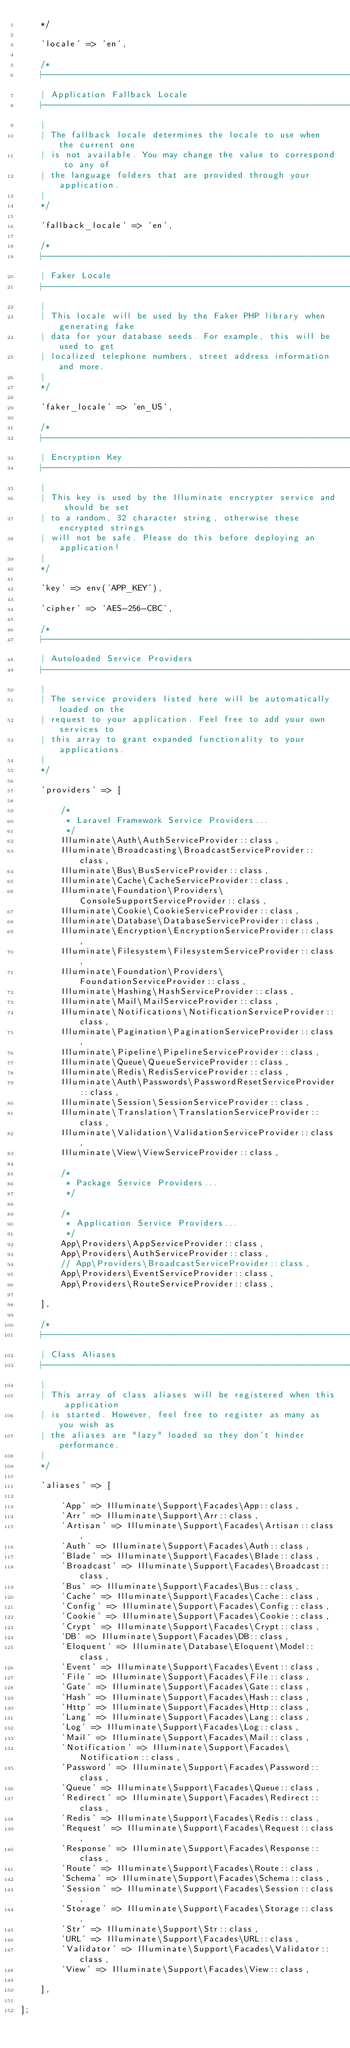Convert code to text. <code><loc_0><loc_0><loc_500><loc_500><_PHP_>    */

    'locale' => 'en',

    /*
    |--------------------------------------------------------------------------
    | Application Fallback Locale
    |--------------------------------------------------------------------------
    |
    | The fallback locale determines the locale to use when the current one
    | is not available. You may change the value to correspond to any of
    | the language folders that are provided through your application.
    |
    */

    'fallback_locale' => 'en',

    /*
    |--------------------------------------------------------------------------
    | Faker Locale
    |--------------------------------------------------------------------------
    |
    | This locale will be used by the Faker PHP library when generating fake
    | data for your database seeds. For example, this will be used to get
    | localized telephone numbers, street address information and more.
    |
    */

    'faker_locale' => 'en_US',

    /*
    |--------------------------------------------------------------------------
    | Encryption Key
    |--------------------------------------------------------------------------
    |
    | This key is used by the Illuminate encrypter service and should be set
    | to a random, 32 character string, otherwise these encrypted strings
    | will not be safe. Please do this before deploying an application!
    |
    */

    'key' => env('APP_KEY'),

    'cipher' => 'AES-256-CBC',

    /*
    |--------------------------------------------------------------------------
    | Autoloaded Service Providers
    |--------------------------------------------------------------------------
    |
    | The service providers listed here will be automatically loaded on the
    | request to your application. Feel free to add your own services to
    | this array to grant expanded functionality to your applications.
    |
    */

    'providers' => [

        /*
         * Laravel Framework Service Providers...
         */
        Illuminate\Auth\AuthServiceProvider::class,
        Illuminate\Broadcasting\BroadcastServiceProvider::class,
        Illuminate\Bus\BusServiceProvider::class,
        Illuminate\Cache\CacheServiceProvider::class,
        Illuminate\Foundation\Providers\ConsoleSupportServiceProvider::class,
        Illuminate\Cookie\CookieServiceProvider::class,
        Illuminate\Database\DatabaseServiceProvider::class,
        Illuminate\Encryption\EncryptionServiceProvider::class,
        Illuminate\Filesystem\FilesystemServiceProvider::class,
        Illuminate\Foundation\Providers\FoundationServiceProvider::class,
        Illuminate\Hashing\HashServiceProvider::class,
        Illuminate\Mail\MailServiceProvider::class,
        Illuminate\Notifications\NotificationServiceProvider::class,
        Illuminate\Pagination\PaginationServiceProvider::class,
        Illuminate\Pipeline\PipelineServiceProvider::class,
        Illuminate\Queue\QueueServiceProvider::class,
        Illuminate\Redis\RedisServiceProvider::class,
        Illuminate\Auth\Passwords\PasswordResetServiceProvider::class,
        Illuminate\Session\SessionServiceProvider::class,
        Illuminate\Translation\TranslationServiceProvider::class,
        Illuminate\Validation\ValidationServiceProvider::class,
        Illuminate\View\ViewServiceProvider::class,

        /*
         * Package Service Providers...
         */

        /*
         * Application Service Providers...
         */
        App\Providers\AppServiceProvider::class,
        App\Providers\AuthServiceProvider::class,
        // App\Providers\BroadcastServiceProvider::class,
        App\Providers\EventServiceProvider::class,
        App\Providers\RouteServiceProvider::class,

    ],

    /*
    |--------------------------------------------------------------------------
    | Class Aliases
    |--------------------------------------------------------------------------
    |
    | This array of class aliases will be registered when this application
    | is started. However, feel free to register as many as you wish as
    | the aliases are "lazy" loaded so they don't hinder performance.
    |
    */

    'aliases' => [

        'App' => Illuminate\Support\Facades\App::class,
        'Arr' => Illuminate\Support\Arr::class,
        'Artisan' => Illuminate\Support\Facades\Artisan::class,
        'Auth' => Illuminate\Support\Facades\Auth::class,
        'Blade' => Illuminate\Support\Facades\Blade::class,
        'Broadcast' => Illuminate\Support\Facades\Broadcast::class,
        'Bus' => Illuminate\Support\Facades\Bus::class,
        'Cache' => Illuminate\Support\Facades\Cache::class,
        'Config' => Illuminate\Support\Facades\Config::class,
        'Cookie' => Illuminate\Support\Facades\Cookie::class,
        'Crypt' => Illuminate\Support\Facades\Crypt::class,
        'DB' => Illuminate\Support\Facades\DB::class,
        'Eloquent' => Illuminate\Database\Eloquent\Model::class,
        'Event' => Illuminate\Support\Facades\Event::class,
        'File' => Illuminate\Support\Facades\File::class,
        'Gate' => Illuminate\Support\Facades\Gate::class,
        'Hash' => Illuminate\Support\Facades\Hash::class,
        'Http' => Illuminate\Support\Facades\Http::class,
        'Lang' => Illuminate\Support\Facades\Lang::class,
        'Log' => Illuminate\Support\Facades\Log::class,
        'Mail' => Illuminate\Support\Facades\Mail::class,
        'Notification' => Illuminate\Support\Facades\Notification::class,
        'Password' => Illuminate\Support\Facades\Password::class,
        'Queue' => Illuminate\Support\Facades\Queue::class,
        'Redirect' => Illuminate\Support\Facades\Redirect::class,
        'Redis' => Illuminate\Support\Facades\Redis::class,
        'Request' => Illuminate\Support\Facades\Request::class,
        'Response' => Illuminate\Support\Facades\Response::class,
        'Route' => Illuminate\Support\Facades\Route::class,
        'Schema' => Illuminate\Support\Facades\Schema::class,
        'Session' => Illuminate\Support\Facades\Session::class,
        'Storage' => Illuminate\Support\Facades\Storage::class,
        'Str' => Illuminate\Support\Str::class,
        'URL' => Illuminate\Support\Facades\URL::class,
        'Validator' => Illuminate\Support\Facades\Validator::class,
        'View' => Illuminate\Support\Facades\View::class,

    ],

];
</code> 